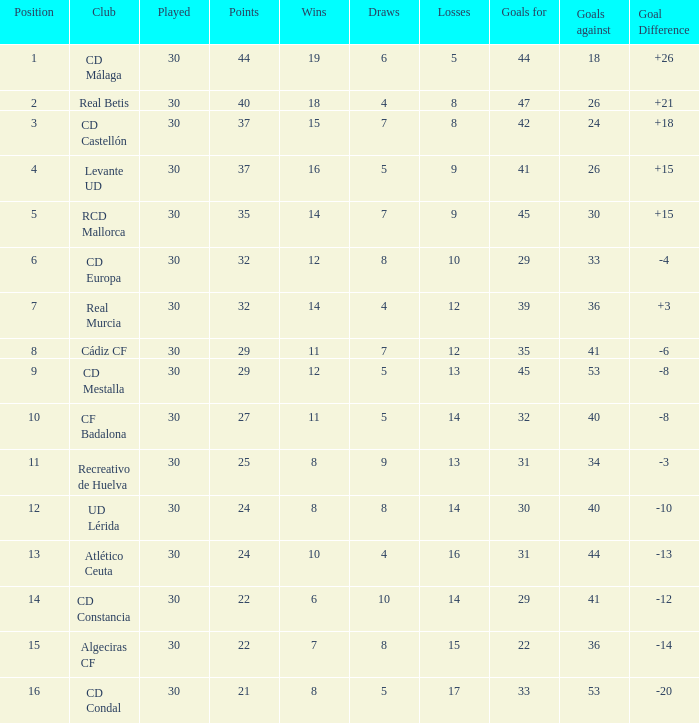What is the number of triumphs when the points were less than 27, and goals conceded reached 41? 6.0. 